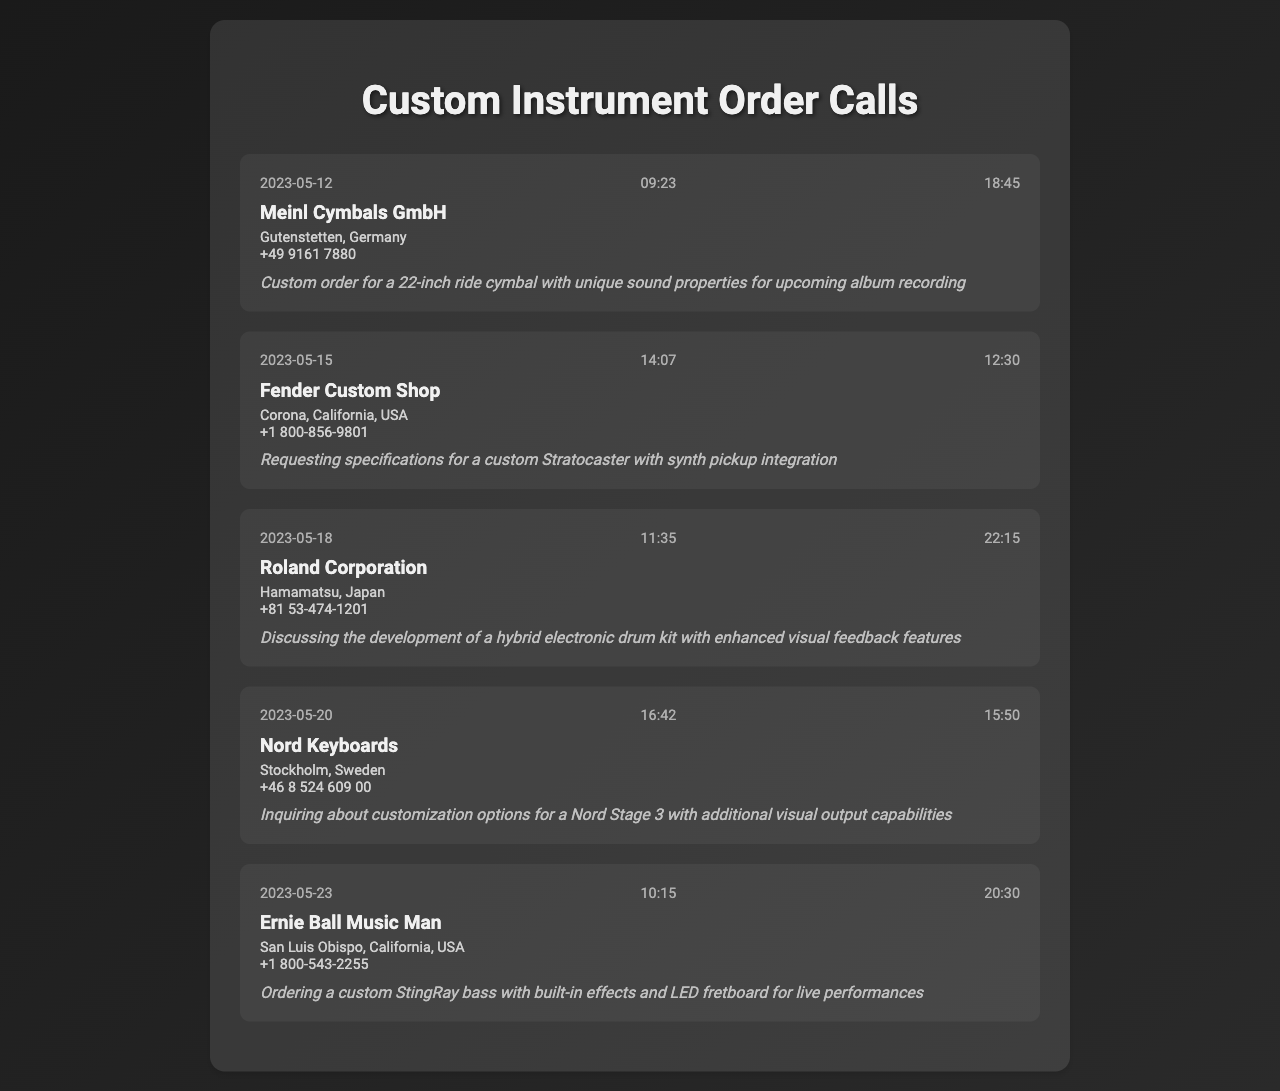what is the date of the call to Meinl Cymbals GmbH? The call to Meinl Cymbals GmbH was made on May 12, 2023.
Answer: May 12, 2023 what is the duration of the call to Fender Custom Shop? The duration of the call to Fender Custom Shop was 12 minutes and 30 seconds.
Answer: 12:30 what location is Ernie Ball Music Man based in? Ernie Ball Music Man is based in San Luis Obispo, California, USA.
Answer: San Luis Obispo, California, USA what specific request was made during the call to Roland Corporation? The request during the call to Roland Corporation was about the development of a hybrid electronic drum kit.
Answer: hybrid electronic drum kit how many calls were made to companies located in the USA? There were three calls made to companies located in the USA (Fender Custom Shop, Ernie Ball Music Man, Meinl Cymbals GmbH).
Answer: 3 which call discussed visual feedback features? The call discussing visual feedback features was with Roland Corporation.
Answer: Roland Corporation what type of instrument was ordered from Meinl Cymbals GmbH? A 22-inch ride cymbal was ordered from Meinl Cymbals GmbH.
Answer: 22-inch ride cymbal which instrument manufacturer was contacted on May 18, 2023? The instrument manufacturer contacted on May 18, 2023, was Roland Corporation.
Answer: Roland Corporation what purpose is mentioned for the call to Nord Keyboards? The purpose of the call to Nord Keyboards was to inquire about customization options for a Nord Stage 3.
Answer: customization options for a Nord Stage 3 